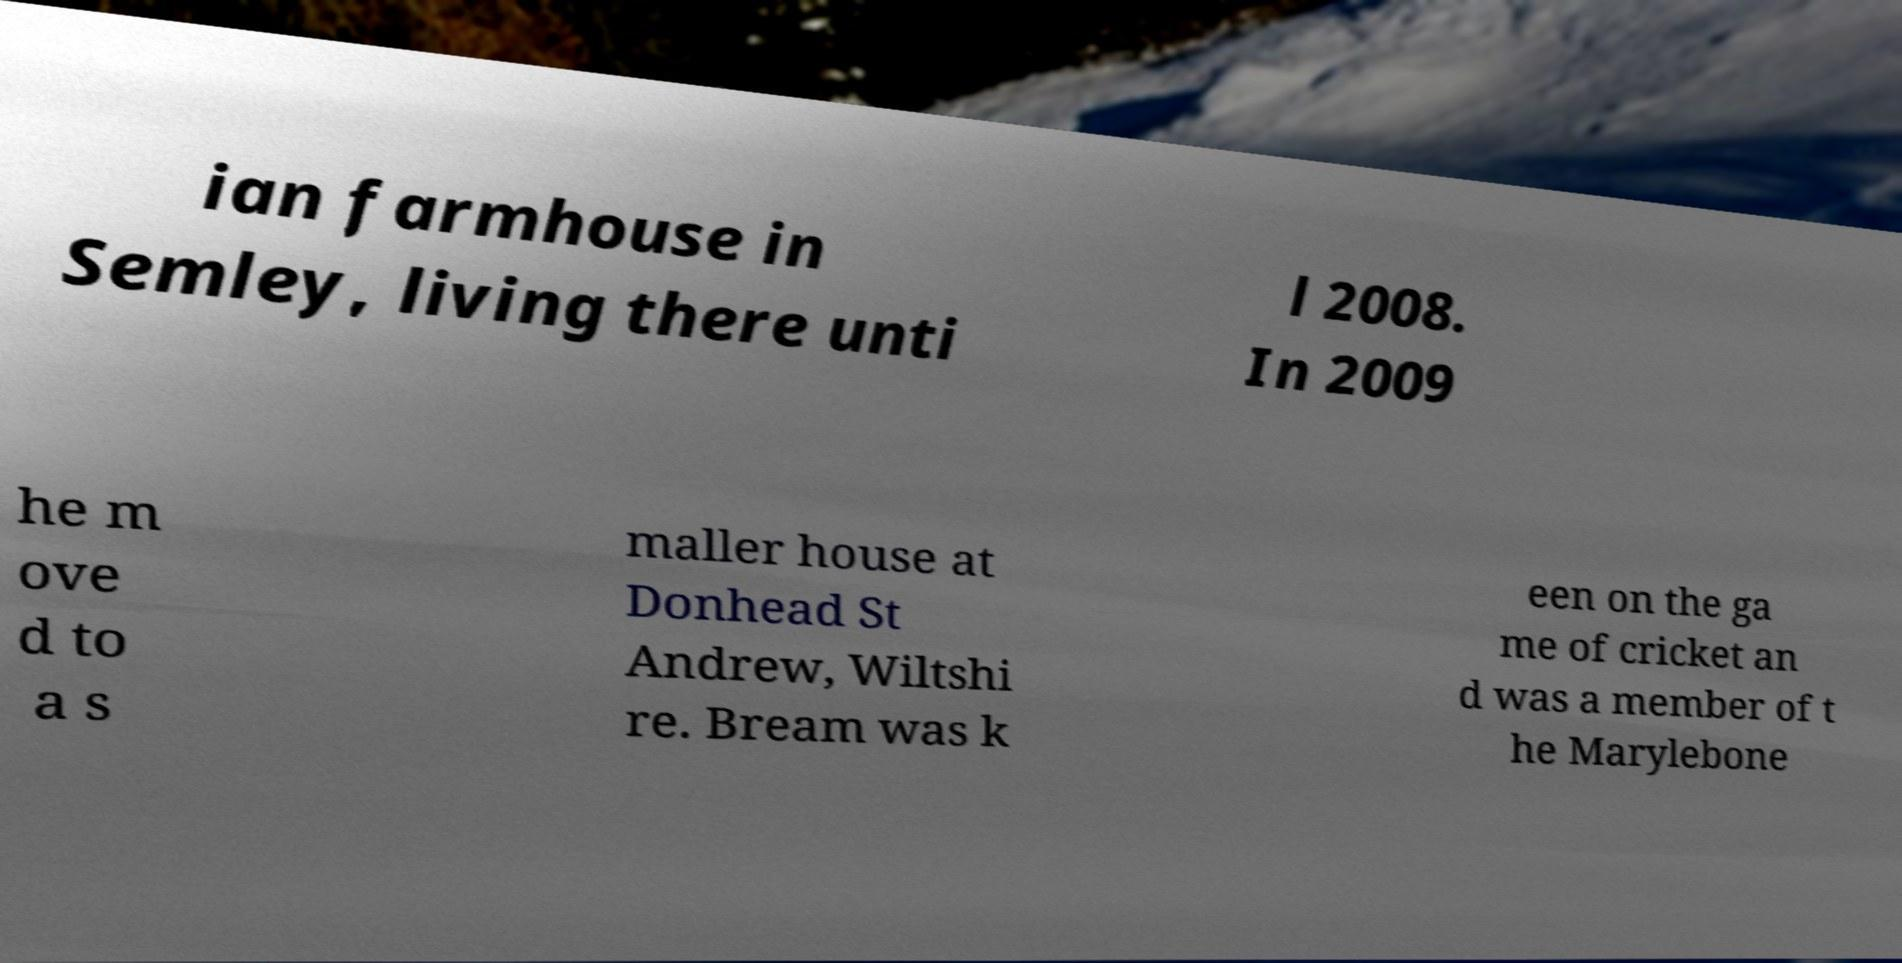Please read and relay the text visible in this image. What does it say? ian farmhouse in Semley, living there unti l 2008. In 2009 he m ove d to a s maller house at Donhead St Andrew, Wiltshi re. Bream was k een on the ga me of cricket an d was a member of t he Marylebone 